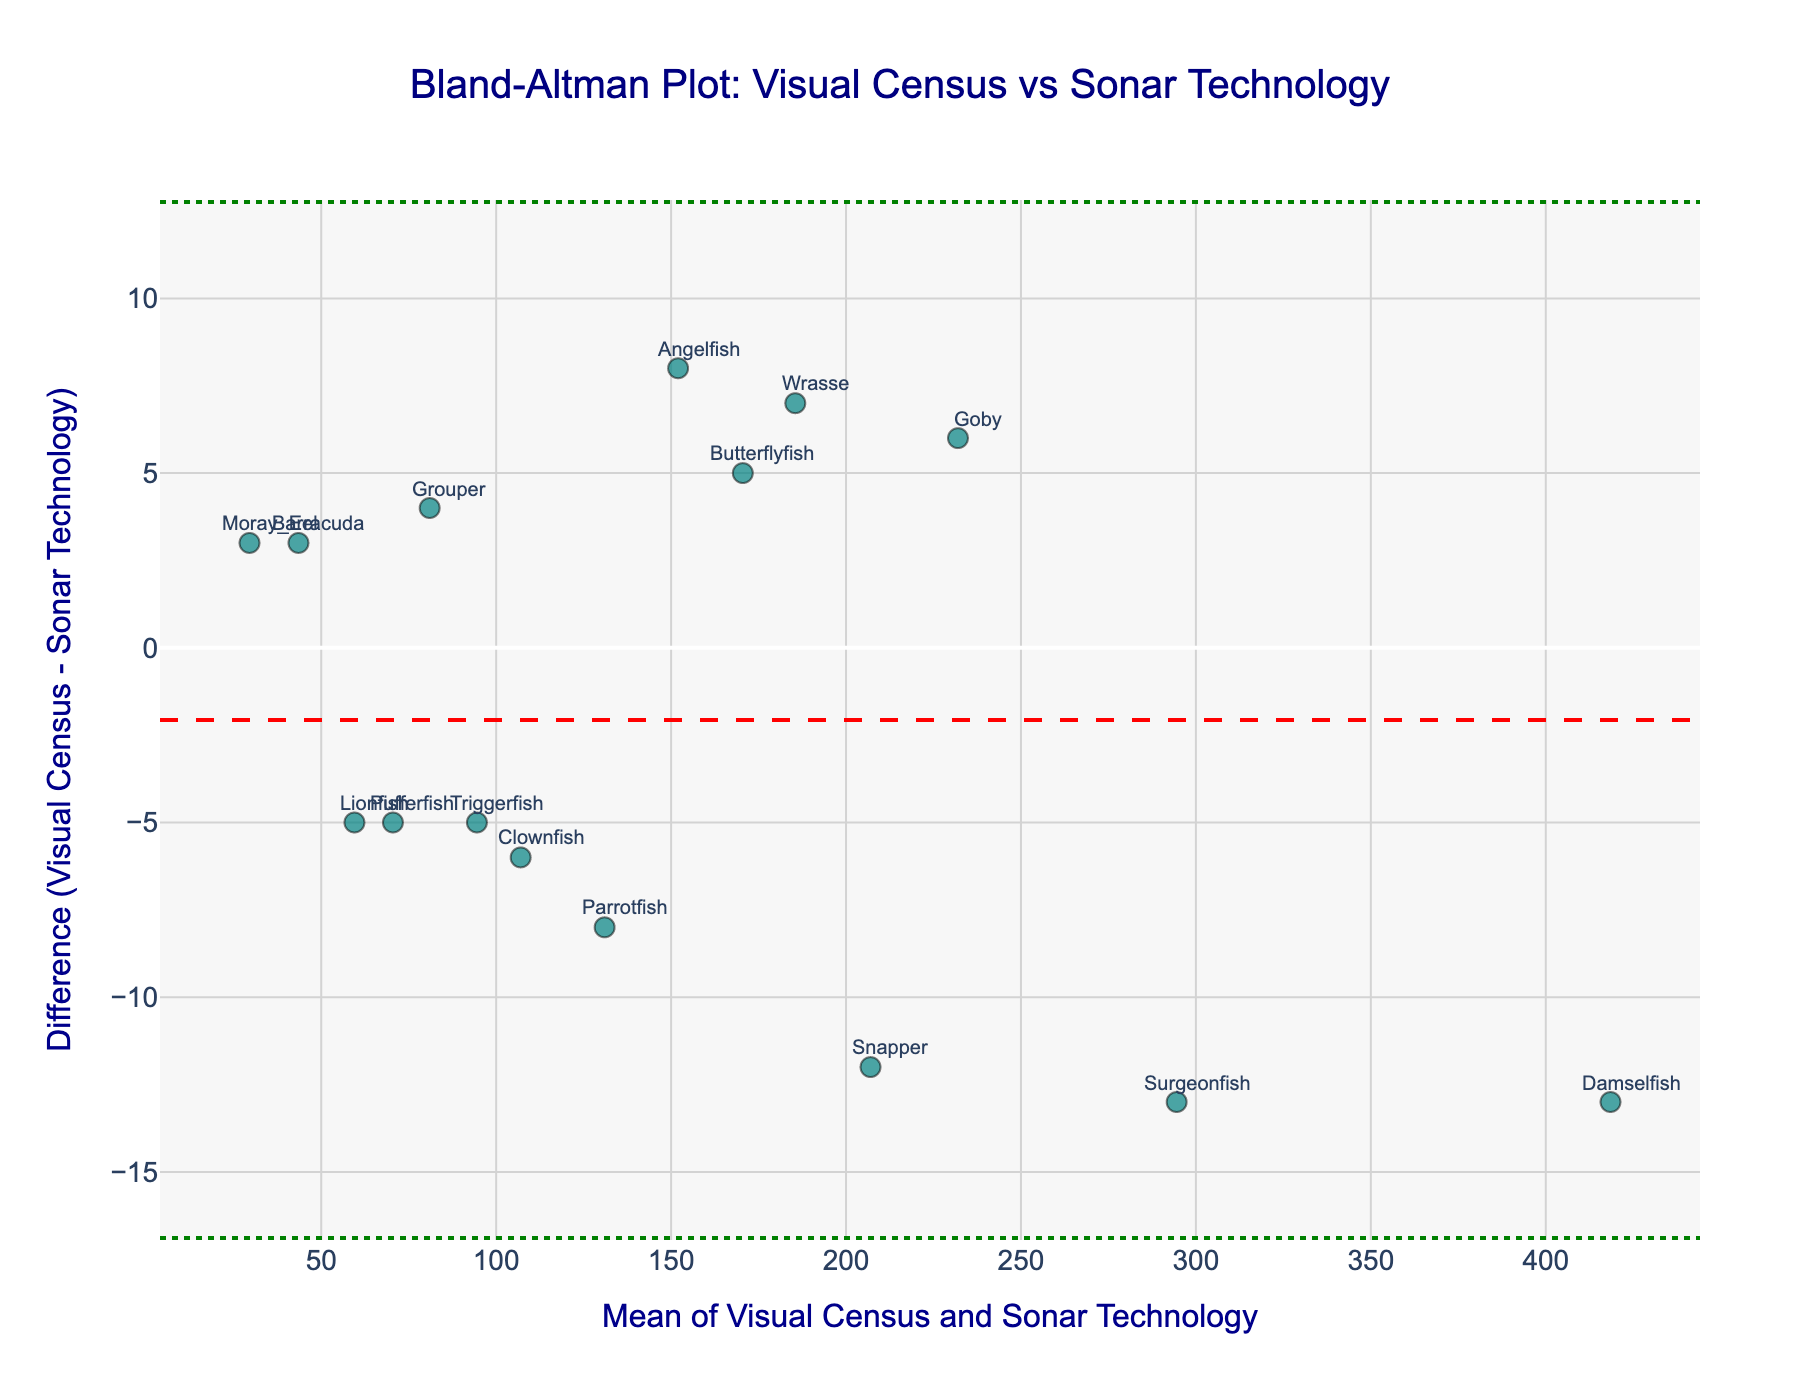How many data points are displayed in the plot? Count the number of markers representing the different fish species in the plot.
Answer: 15 What is the title of the plot? Look at the text displayed prominently at the top of the graph.
Answer: Bland-Altman Plot: Visual Census vs Sonar Technology What does the y-axis represent? Read the axis label on the y-axis.
Answer: Difference (Visual Census - Sonar Technology) What color are the markers representing the data points? Observe the color of the markers in the scatter plot.
Answer: Teal What does the mean difference line represent in this plot? This line shows the average of the differences between the Visual Census and Sonar Technology values.
Answer: The average difference between the two methods How many fish species have a positive difference? Count the markers that are above the zero line on the y-axis.
Answer: 8 What are the limits of agreement in this plot? Identify the values where the green dotted lines intersect the y-axis.
Answer: Approximately -11 and 19 Which fish species has the highest positive difference, and what is the value? Look at the markers above the zero line on the y-axis and identify the one farthest from it. Then note the corresponding difference value.
Answer: Barracuda, 3 Which fish species has the maximum mean value, and what is it? Find the data point furthest to the right on the x-axis and note down the corresponding mean value.
Answer: Damselfish, 418.5 What is the difference value for Snapper? Identify the data point labeled "Snapper" and note the position relative to the y-axis.
Answer: -12 